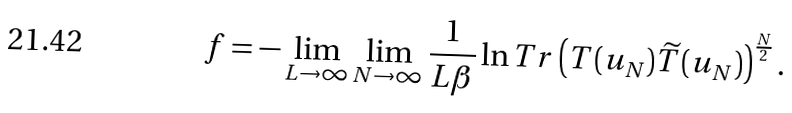<formula> <loc_0><loc_0><loc_500><loc_500>f = - \lim _ { L \to \infty } \lim _ { N \to \infty } \frac { 1 } { L \beta } \ln T r \left ( T ( u _ { N } ) \widetilde { T } ( u _ { N } ) \right ) ^ { \frac { N } { 2 } } .</formula> 